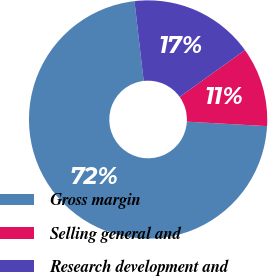Convert chart. <chart><loc_0><loc_0><loc_500><loc_500><pie_chart><fcel>Gross margin<fcel>Selling general and<fcel>Research development and<nl><fcel>72.29%<fcel>10.78%<fcel>16.93%<nl></chart> 